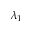Convert formula to latex. <formula><loc_0><loc_0><loc_500><loc_500>\lambda _ { 1 }</formula> 